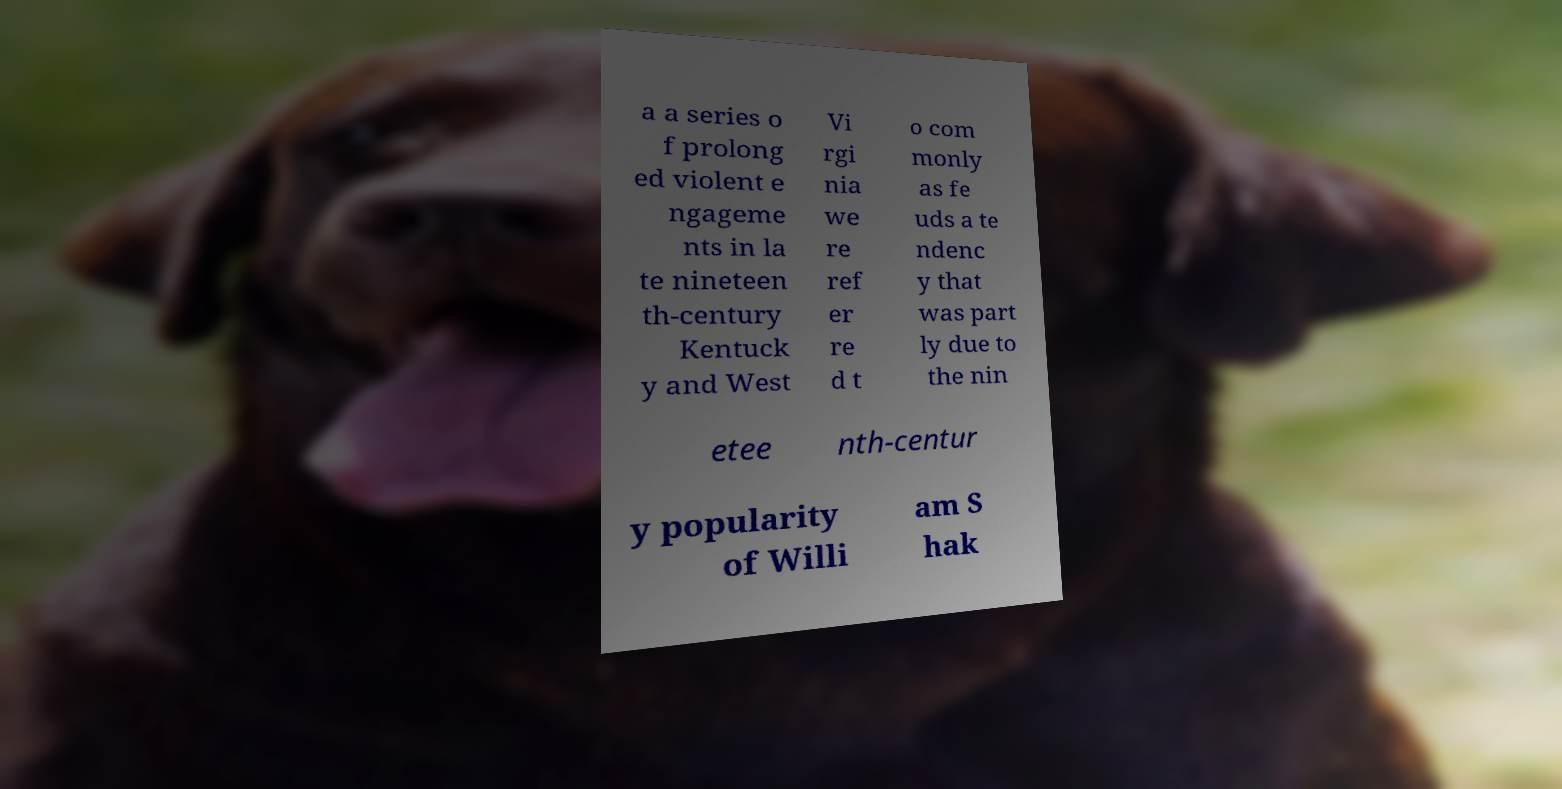Can you accurately transcribe the text from the provided image for me? a a series o f prolong ed violent e ngageme nts in la te nineteen th-century Kentuck y and West Vi rgi nia we re ref er re d t o com monly as fe uds a te ndenc y that was part ly due to the nin etee nth-centur y popularity of Willi am S hak 